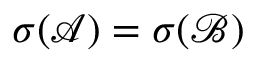<formula> <loc_0><loc_0><loc_500><loc_500>\sigma ( { \mathcal { A } } ) = \sigma ( { \mathcal { B } } )</formula> 